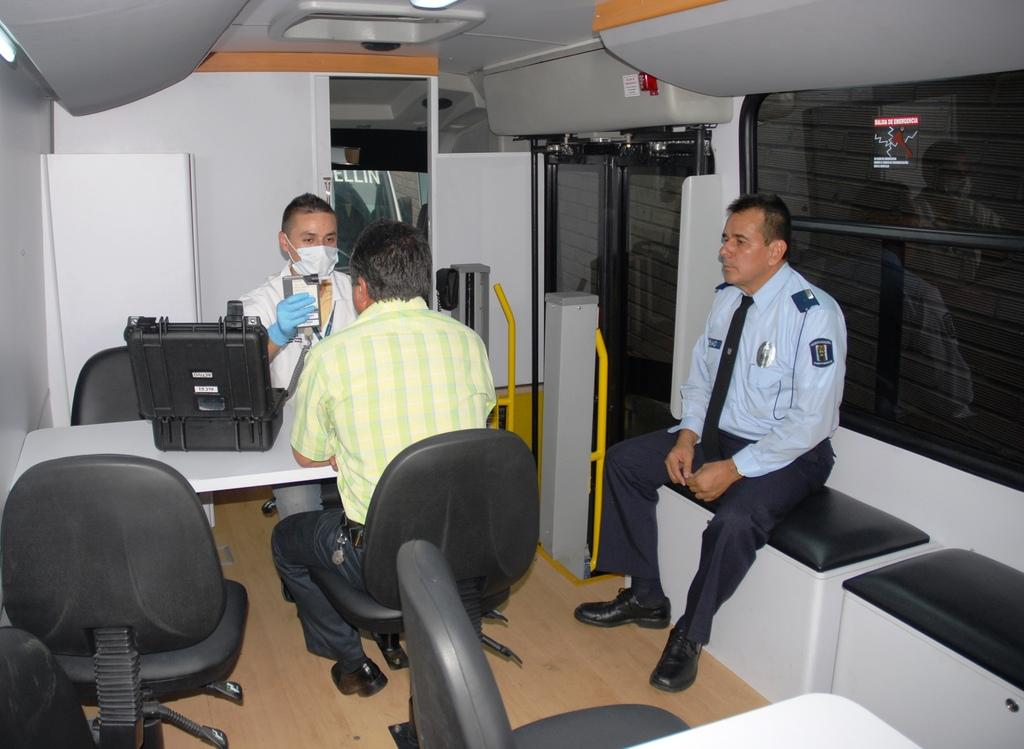How many men are in the image? There are three men in the image. What are the men doing in the image? The men are sitting. What object can be seen on a table in the image? There is a suitcase on a table in the image. What type of furniture is present in the image? There are chairs in the image. What architectural features can be seen in the image? There is a door and a window in the image. What type of authority does the man in the middle have in the image? There is no indication of authority in the image; it only shows three men sitting. What question is being asked by the man on the left in the image? There is no indication of a question being asked in the image; the men are simply sitting. 